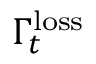<formula> <loc_0><loc_0><loc_500><loc_500>\Gamma _ { t } ^ { l o s s }</formula> 